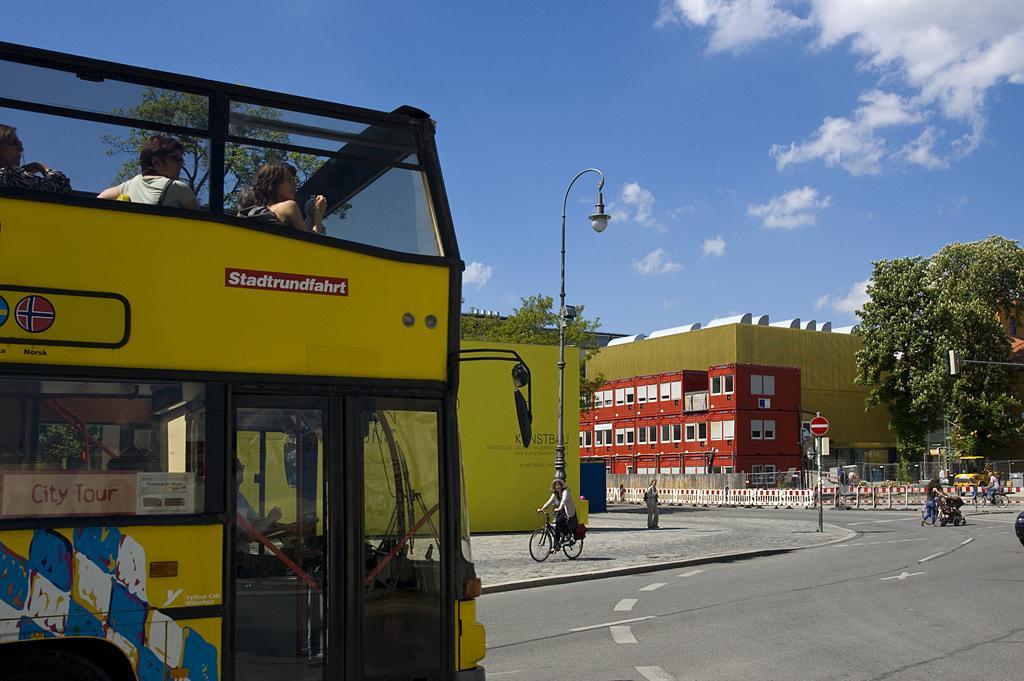Could you give a brief overview of what you see in this image? In this picture we can see a group of people sitting in a Double Decker Bus and the bus is on the road. Behind the people there is a person riding a bicycle on the path and a woman is pushing the stroller. Behind the people there is a pole with light and another pole with sign board, trees, buildings and a sky. 